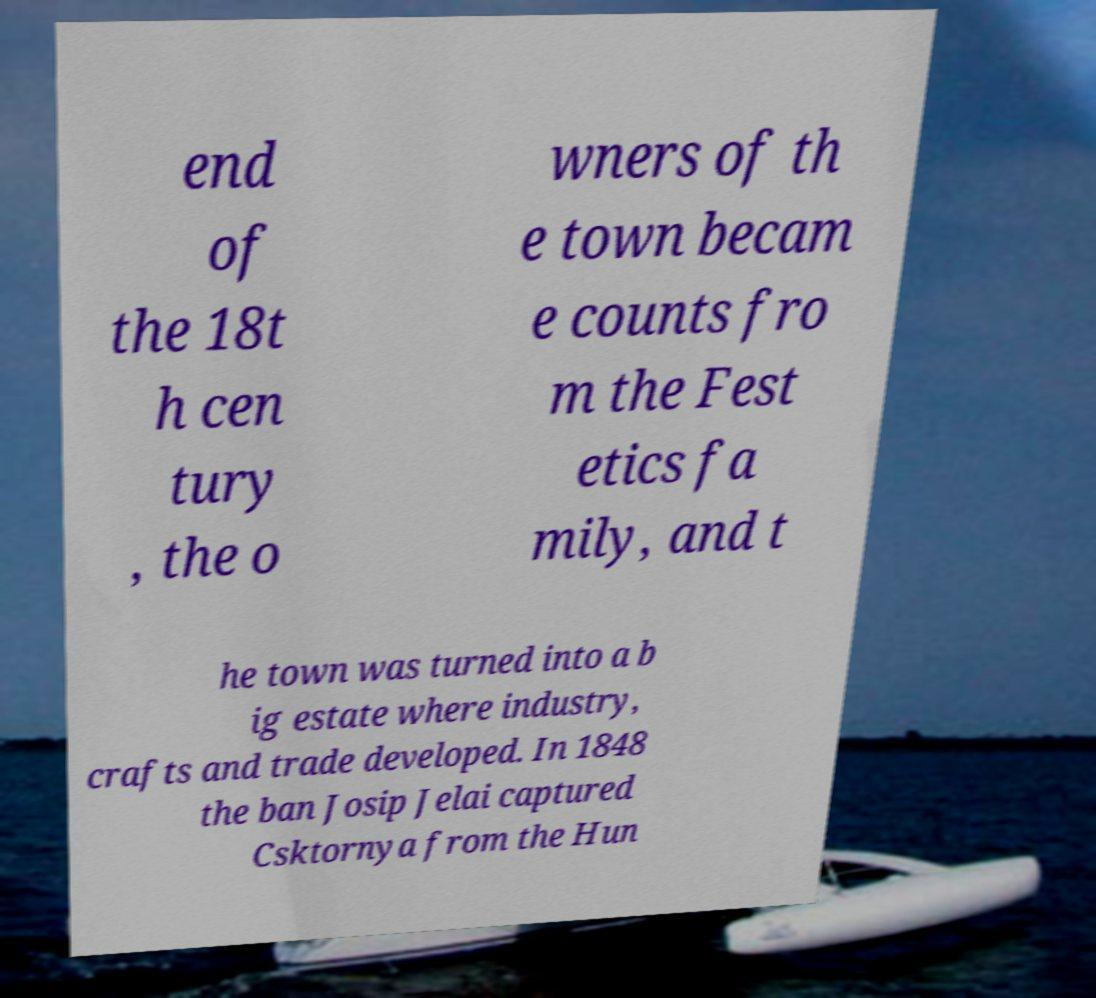For documentation purposes, I need the text within this image transcribed. Could you provide that? end of the 18t h cen tury , the o wners of th e town becam e counts fro m the Fest etics fa mily, and t he town was turned into a b ig estate where industry, crafts and trade developed. In 1848 the ban Josip Jelai captured Csktornya from the Hun 